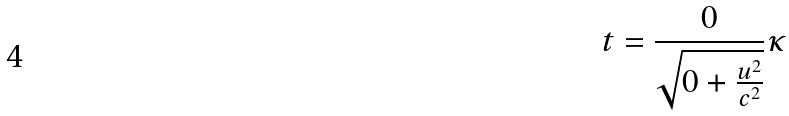Convert formula to latex. <formula><loc_0><loc_0><loc_500><loc_500>t = \frac { 0 } { \sqrt { 0 + \frac { u ^ { 2 } } { c ^ { 2 } } } } \kappa</formula> 